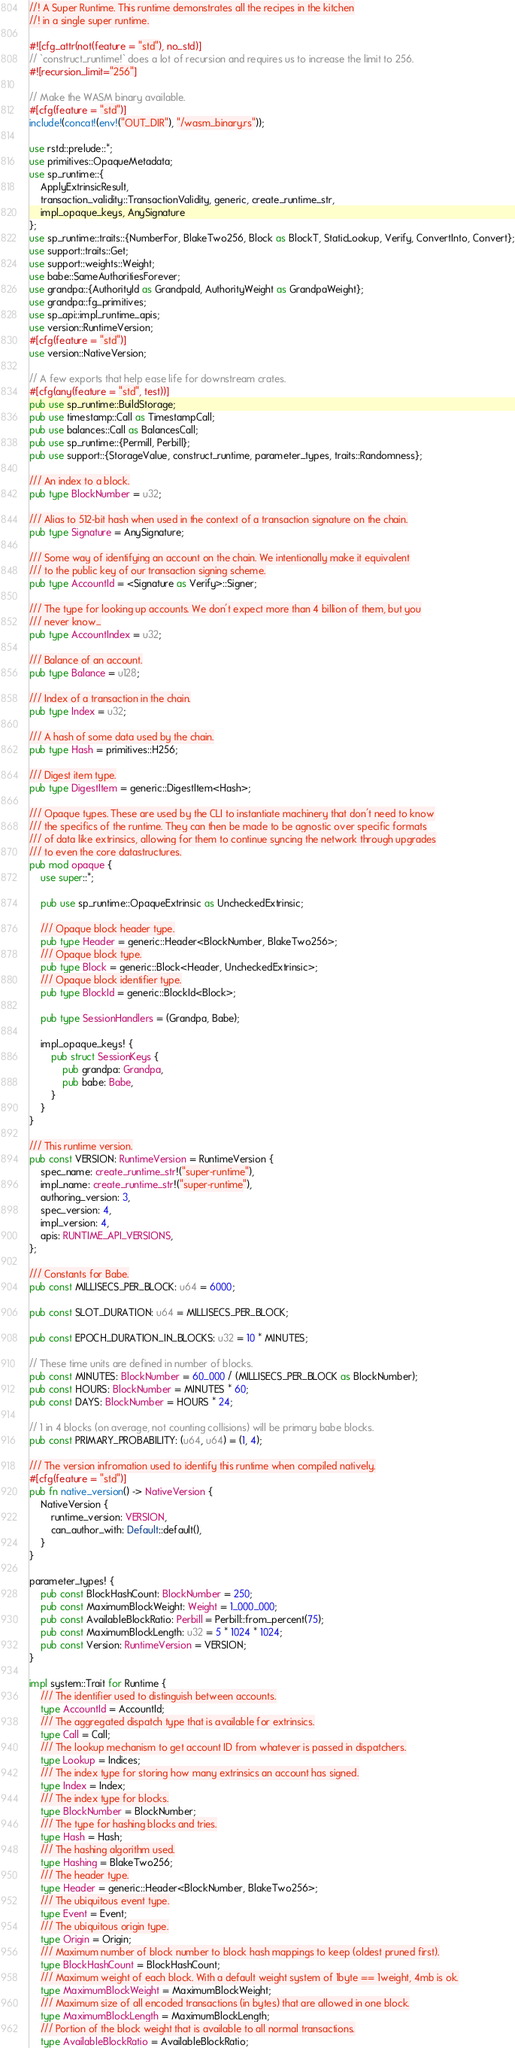Convert code to text. <code><loc_0><loc_0><loc_500><loc_500><_Rust_>//! A Super Runtime. This runtime demonstrates all the recipes in the kitchen
//! in a single super runtime.

#![cfg_attr(not(feature = "std"), no_std)]
// `construct_runtime!` does a lot of recursion and requires us to increase the limit to 256.
#![recursion_limit="256"]

// Make the WASM binary available.
#[cfg(feature = "std")]
include!(concat!(env!("OUT_DIR"), "/wasm_binary.rs"));

use rstd::prelude::*;
use primitives::OpaqueMetadata;
use sp_runtime::{
    ApplyExtrinsicResult,
	transaction_validity::TransactionValidity, generic, create_runtime_str,
	impl_opaque_keys, AnySignature
};
use sp_runtime::traits::{NumberFor, BlakeTwo256, Block as BlockT, StaticLookup, Verify, ConvertInto, Convert};
use support::traits::Get;
use support::weights::Weight;
use babe::SameAuthoritiesForever;
use grandpa::{AuthorityId as GrandpaId, AuthorityWeight as GrandpaWeight};
use grandpa::fg_primitives;
use sp_api::impl_runtime_apis;
use version::RuntimeVersion;
#[cfg(feature = "std")]
use version::NativeVersion;

// A few exports that help ease life for downstream crates.
#[cfg(any(feature = "std", test))]
pub use sp_runtime::BuildStorage;
pub use timestamp::Call as TimestampCall;
pub use balances::Call as BalancesCall;
pub use sp_runtime::{Permill, Perbill};
pub use support::{StorageValue, construct_runtime, parameter_types, traits::Randomness};

/// An index to a block.
pub type BlockNumber = u32;

/// Alias to 512-bit hash when used in the context of a transaction signature on the chain.
pub type Signature = AnySignature;

/// Some way of identifying an account on the chain. We intentionally make it equivalent
/// to the public key of our transaction signing scheme.
pub type AccountId = <Signature as Verify>::Signer;

/// The type for looking up accounts. We don't expect more than 4 billion of them, but you
/// never know...
pub type AccountIndex = u32;

/// Balance of an account.
pub type Balance = u128;

/// Index of a transaction in the chain.
pub type Index = u32;

/// A hash of some data used by the chain.
pub type Hash = primitives::H256;

/// Digest item type.
pub type DigestItem = generic::DigestItem<Hash>;

/// Opaque types. These are used by the CLI to instantiate machinery that don't need to know
/// the specifics of the runtime. They can then be made to be agnostic over specific formats
/// of data like extrinsics, allowing for them to continue syncing the network through upgrades
/// to even the core datastructures.
pub mod opaque {
	use super::*;

	pub use sp_runtime::OpaqueExtrinsic as UncheckedExtrinsic;

	/// Opaque block header type.
	pub type Header = generic::Header<BlockNumber, BlakeTwo256>;
	/// Opaque block type.
	pub type Block = generic::Block<Header, UncheckedExtrinsic>;
	/// Opaque block identifier type.
	pub type BlockId = generic::BlockId<Block>;

	pub type SessionHandlers = (Grandpa, Babe);

	impl_opaque_keys! {
		pub struct SessionKeys {
			pub grandpa: Grandpa,
			pub babe: Babe,
		}
	}
}

/// This runtime version.
pub const VERSION: RuntimeVersion = RuntimeVersion {
	spec_name: create_runtime_str!("super-runtime"),
	impl_name: create_runtime_str!("super-runtime"),
	authoring_version: 3,
	spec_version: 4,
	impl_version: 4,
	apis: RUNTIME_API_VERSIONS,
};

/// Constants for Babe.
pub const MILLISECS_PER_BLOCK: u64 = 6000;

pub const SLOT_DURATION: u64 = MILLISECS_PER_BLOCK;

pub const EPOCH_DURATION_IN_BLOCKS: u32 = 10 * MINUTES;

// These time units are defined in number of blocks.
pub const MINUTES: BlockNumber = 60_000 / (MILLISECS_PER_BLOCK as BlockNumber);
pub const HOURS: BlockNumber = MINUTES * 60;
pub const DAYS: BlockNumber = HOURS * 24;

// 1 in 4 blocks (on average, not counting collisions) will be primary babe blocks.
pub const PRIMARY_PROBABILITY: (u64, u64) = (1, 4);

/// The version infromation used to identify this runtime when compiled natively.
#[cfg(feature = "std")]
pub fn native_version() -> NativeVersion {
	NativeVersion {
		runtime_version: VERSION,
		can_author_with: Default::default(),
	}
}

parameter_types! {
	pub const BlockHashCount: BlockNumber = 250;
	pub const MaximumBlockWeight: Weight = 1_000_000;
	pub const AvailableBlockRatio: Perbill = Perbill::from_percent(75);
	pub const MaximumBlockLength: u32 = 5 * 1024 * 1024;
	pub const Version: RuntimeVersion = VERSION;
}

impl system::Trait for Runtime {
	/// The identifier used to distinguish between accounts.
	type AccountId = AccountId;
	/// The aggregated dispatch type that is available for extrinsics.
	type Call = Call;
	/// The lookup mechanism to get account ID from whatever is passed in dispatchers.
	type Lookup = Indices;
	/// The index type for storing how many extrinsics an account has signed.
	type Index = Index;
	/// The index type for blocks.
	type BlockNumber = BlockNumber;
	/// The type for hashing blocks and tries.
	type Hash = Hash;
	/// The hashing algorithm used.
	type Hashing = BlakeTwo256;
	/// The header type.
	type Header = generic::Header<BlockNumber, BlakeTwo256>;
	/// The ubiquitous event type.
	type Event = Event;
	/// The ubiquitous origin type.
	type Origin = Origin;
	/// Maximum number of block number to block hash mappings to keep (oldest pruned first).
	type BlockHashCount = BlockHashCount;
	/// Maximum weight of each block. With a default weight system of 1byte == 1weight, 4mb is ok.
	type MaximumBlockWeight = MaximumBlockWeight;
	/// Maximum size of all encoded transactions (in bytes) that are allowed in one block.
	type MaximumBlockLength = MaximumBlockLength;
	/// Portion of the block weight that is available to all normal transactions.
	type AvailableBlockRatio = AvailableBlockRatio;</code> 